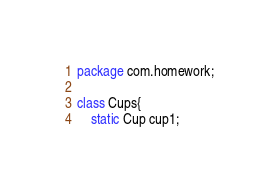Convert code to text. <code><loc_0><loc_0><loc_500><loc_500><_Java_>package com.homework;

class Cups{
    static Cup cup1;</code> 